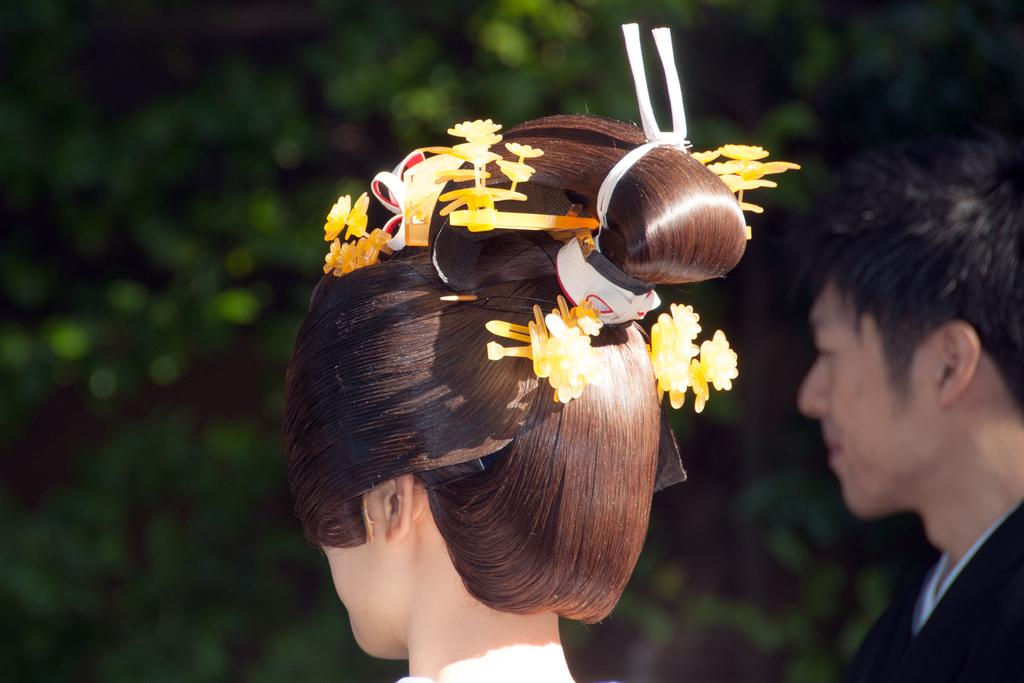How many people are present in the image? There is a man and a woman in the image. What can be seen in the background of the image? Greenery is visible in the background of the image. What type of liquid is being protested by the plant in the image? There is no liquid or protest present in the image; it features a man, a woman, and greenery in the background. 